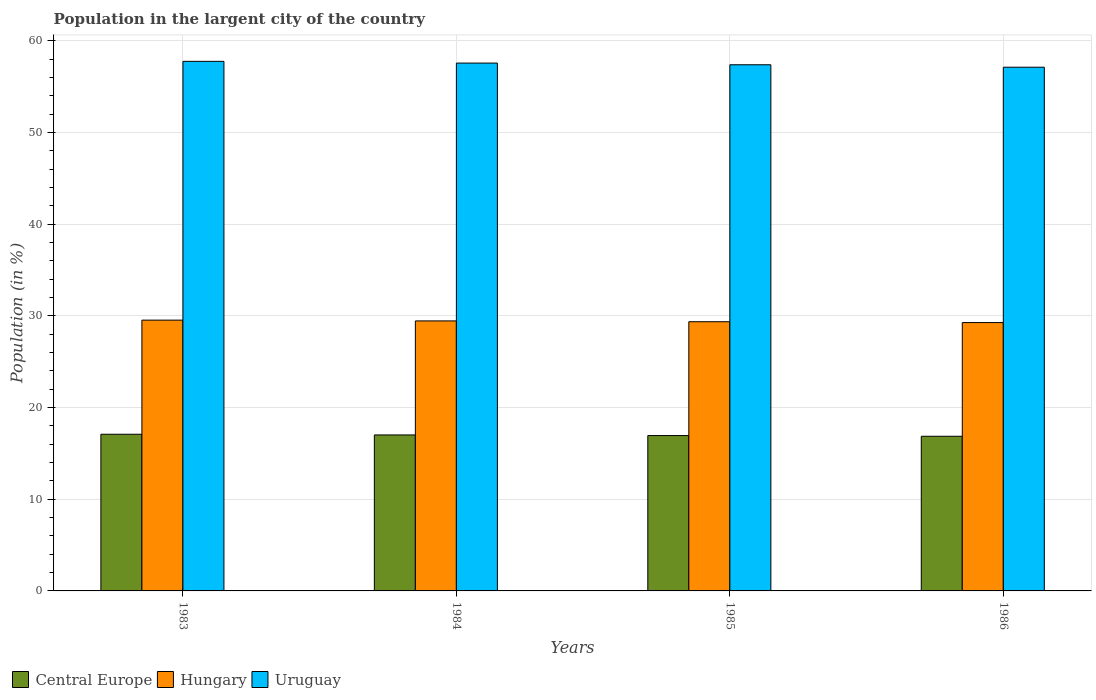How many different coloured bars are there?
Your answer should be compact. 3. How many groups of bars are there?
Your answer should be compact. 4. Are the number of bars on each tick of the X-axis equal?
Offer a terse response. Yes. How many bars are there on the 1st tick from the right?
Keep it short and to the point. 3. In how many cases, is the number of bars for a given year not equal to the number of legend labels?
Offer a very short reply. 0. What is the percentage of population in the largent city in Uruguay in 1983?
Give a very brief answer. 57.78. Across all years, what is the maximum percentage of population in the largent city in Uruguay?
Provide a short and direct response. 57.78. Across all years, what is the minimum percentage of population in the largent city in Central Europe?
Your answer should be compact. 16.87. In which year was the percentage of population in the largent city in Uruguay maximum?
Provide a short and direct response. 1983. What is the total percentage of population in the largent city in Uruguay in the graph?
Offer a very short reply. 229.9. What is the difference between the percentage of population in the largent city in Central Europe in 1985 and that in 1986?
Give a very brief answer. 0.08. What is the difference between the percentage of population in the largent city in Central Europe in 1985 and the percentage of population in the largent city in Hungary in 1984?
Offer a very short reply. -12.51. What is the average percentage of population in the largent city in Uruguay per year?
Offer a very short reply. 57.48. In the year 1986, what is the difference between the percentage of population in the largent city in Central Europe and percentage of population in the largent city in Uruguay?
Provide a short and direct response. -40.27. What is the ratio of the percentage of population in the largent city in Uruguay in 1983 to that in 1986?
Your answer should be very brief. 1.01. Is the percentage of population in the largent city in Central Europe in 1984 less than that in 1986?
Provide a short and direct response. No. Is the difference between the percentage of population in the largent city in Central Europe in 1984 and 1986 greater than the difference between the percentage of population in the largent city in Uruguay in 1984 and 1986?
Make the answer very short. No. What is the difference between the highest and the second highest percentage of population in the largent city in Uruguay?
Give a very brief answer. 0.19. What is the difference between the highest and the lowest percentage of population in the largent city in Central Europe?
Offer a very short reply. 0.22. In how many years, is the percentage of population in the largent city in Central Europe greater than the average percentage of population in the largent city in Central Europe taken over all years?
Provide a short and direct response. 2. What does the 1st bar from the left in 1983 represents?
Your response must be concise. Central Europe. What does the 1st bar from the right in 1984 represents?
Offer a terse response. Uruguay. Is it the case that in every year, the sum of the percentage of population in the largent city in Uruguay and percentage of population in the largent city in Hungary is greater than the percentage of population in the largent city in Central Europe?
Give a very brief answer. Yes. How many bars are there?
Give a very brief answer. 12. What is the difference between two consecutive major ticks on the Y-axis?
Provide a succinct answer. 10. How many legend labels are there?
Offer a terse response. 3. How are the legend labels stacked?
Your answer should be very brief. Horizontal. What is the title of the graph?
Your response must be concise. Population in the largent city of the country. What is the Population (in %) in Central Europe in 1983?
Give a very brief answer. 17.09. What is the Population (in %) of Hungary in 1983?
Your response must be concise. 29.54. What is the Population (in %) of Uruguay in 1983?
Make the answer very short. 57.78. What is the Population (in %) in Central Europe in 1984?
Give a very brief answer. 17.02. What is the Population (in %) of Hungary in 1984?
Ensure brevity in your answer.  29.46. What is the Population (in %) in Uruguay in 1984?
Offer a very short reply. 57.59. What is the Population (in %) of Central Europe in 1985?
Ensure brevity in your answer.  16.95. What is the Population (in %) in Hungary in 1985?
Offer a terse response. 29.37. What is the Population (in %) of Uruguay in 1985?
Your answer should be very brief. 57.4. What is the Population (in %) of Central Europe in 1986?
Offer a very short reply. 16.87. What is the Population (in %) in Hungary in 1986?
Provide a short and direct response. 29.28. What is the Population (in %) of Uruguay in 1986?
Offer a very short reply. 57.14. Across all years, what is the maximum Population (in %) of Central Europe?
Make the answer very short. 17.09. Across all years, what is the maximum Population (in %) of Hungary?
Make the answer very short. 29.54. Across all years, what is the maximum Population (in %) in Uruguay?
Offer a very short reply. 57.78. Across all years, what is the minimum Population (in %) in Central Europe?
Your answer should be compact. 16.87. Across all years, what is the minimum Population (in %) in Hungary?
Your answer should be very brief. 29.28. Across all years, what is the minimum Population (in %) in Uruguay?
Make the answer very short. 57.14. What is the total Population (in %) in Central Europe in the graph?
Keep it short and to the point. 67.93. What is the total Population (in %) of Hungary in the graph?
Your answer should be compact. 117.65. What is the total Population (in %) of Uruguay in the graph?
Ensure brevity in your answer.  229.9. What is the difference between the Population (in %) of Central Europe in 1983 and that in 1984?
Make the answer very short. 0.07. What is the difference between the Population (in %) in Hungary in 1983 and that in 1984?
Keep it short and to the point. 0.09. What is the difference between the Population (in %) in Uruguay in 1983 and that in 1984?
Make the answer very short. 0.19. What is the difference between the Population (in %) of Central Europe in 1983 and that in 1985?
Give a very brief answer. 0.14. What is the difference between the Population (in %) in Hungary in 1983 and that in 1985?
Offer a terse response. 0.17. What is the difference between the Population (in %) in Uruguay in 1983 and that in 1985?
Make the answer very short. 0.37. What is the difference between the Population (in %) in Central Europe in 1983 and that in 1986?
Ensure brevity in your answer.  0.22. What is the difference between the Population (in %) of Hungary in 1983 and that in 1986?
Ensure brevity in your answer.  0.27. What is the difference between the Population (in %) in Uruguay in 1983 and that in 1986?
Offer a terse response. 0.64. What is the difference between the Population (in %) in Central Europe in 1984 and that in 1985?
Offer a terse response. 0.07. What is the difference between the Population (in %) in Hungary in 1984 and that in 1985?
Keep it short and to the point. 0.09. What is the difference between the Population (in %) of Uruguay in 1984 and that in 1985?
Keep it short and to the point. 0.18. What is the difference between the Population (in %) of Central Europe in 1984 and that in 1986?
Ensure brevity in your answer.  0.14. What is the difference between the Population (in %) of Hungary in 1984 and that in 1986?
Provide a succinct answer. 0.18. What is the difference between the Population (in %) of Uruguay in 1984 and that in 1986?
Offer a terse response. 0.45. What is the difference between the Population (in %) in Central Europe in 1985 and that in 1986?
Make the answer very short. 0.08. What is the difference between the Population (in %) in Hungary in 1985 and that in 1986?
Make the answer very short. 0.09. What is the difference between the Population (in %) in Uruguay in 1985 and that in 1986?
Give a very brief answer. 0.27. What is the difference between the Population (in %) in Central Europe in 1983 and the Population (in %) in Hungary in 1984?
Your answer should be compact. -12.37. What is the difference between the Population (in %) in Central Europe in 1983 and the Population (in %) in Uruguay in 1984?
Your answer should be very brief. -40.49. What is the difference between the Population (in %) in Hungary in 1983 and the Population (in %) in Uruguay in 1984?
Offer a terse response. -28.04. What is the difference between the Population (in %) in Central Europe in 1983 and the Population (in %) in Hungary in 1985?
Your answer should be compact. -12.28. What is the difference between the Population (in %) of Central Europe in 1983 and the Population (in %) of Uruguay in 1985?
Keep it short and to the point. -40.31. What is the difference between the Population (in %) of Hungary in 1983 and the Population (in %) of Uruguay in 1985?
Your answer should be very brief. -27.86. What is the difference between the Population (in %) in Central Europe in 1983 and the Population (in %) in Hungary in 1986?
Ensure brevity in your answer.  -12.19. What is the difference between the Population (in %) in Central Europe in 1983 and the Population (in %) in Uruguay in 1986?
Keep it short and to the point. -40.05. What is the difference between the Population (in %) in Hungary in 1983 and the Population (in %) in Uruguay in 1986?
Your response must be concise. -27.59. What is the difference between the Population (in %) in Central Europe in 1984 and the Population (in %) in Hungary in 1985?
Ensure brevity in your answer.  -12.35. What is the difference between the Population (in %) of Central Europe in 1984 and the Population (in %) of Uruguay in 1985?
Provide a short and direct response. -40.39. What is the difference between the Population (in %) in Hungary in 1984 and the Population (in %) in Uruguay in 1985?
Offer a terse response. -27.95. What is the difference between the Population (in %) in Central Europe in 1984 and the Population (in %) in Hungary in 1986?
Your answer should be compact. -12.26. What is the difference between the Population (in %) in Central Europe in 1984 and the Population (in %) in Uruguay in 1986?
Provide a short and direct response. -40.12. What is the difference between the Population (in %) in Hungary in 1984 and the Population (in %) in Uruguay in 1986?
Your answer should be very brief. -27.68. What is the difference between the Population (in %) in Central Europe in 1985 and the Population (in %) in Hungary in 1986?
Your response must be concise. -12.33. What is the difference between the Population (in %) of Central Europe in 1985 and the Population (in %) of Uruguay in 1986?
Your answer should be very brief. -40.19. What is the difference between the Population (in %) in Hungary in 1985 and the Population (in %) in Uruguay in 1986?
Make the answer very short. -27.77. What is the average Population (in %) in Central Europe per year?
Give a very brief answer. 16.98. What is the average Population (in %) of Hungary per year?
Provide a succinct answer. 29.41. What is the average Population (in %) in Uruguay per year?
Ensure brevity in your answer.  57.48. In the year 1983, what is the difference between the Population (in %) of Central Europe and Population (in %) of Hungary?
Offer a terse response. -12.45. In the year 1983, what is the difference between the Population (in %) in Central Europe and Population (in %) in Uruguay?
Provide a short and direct response. -40.68. In the year 1983, what is the difference between the Population (in %) in Hungary and Population (in %) in Uruguay?
Keep it short and to the point. -28.23. In the year 1984, what is the difference between the Population (in %) in Central Europe and Population (in %) in Hungary?
Offer a very short reply. -12.44. In the year 1984, what is the difference between the Population (in %) in Central Europe and Population (in %) in Uruguay?
Your answer should be very brief. -40.57. In the year 1984, what is the difference between the Population (in %) of Hungary and Population (in %) of Uruguay?
Keep it short and to the point. -28.13. In the year 1985, what is the difference between the Population (in %) of Central Europe and Population (in %) of Hungary?
Your response must be concise. -12.42. In the year 1985, what is the difference between the Population (in %) of Central Europe and Population (in %) of Uruguay?
Your answer should be compact. -40.46. In the year 1985, what is the difference between the Population (in %) of Hungary and Population (in %) of Uruguay?
Provide a succinct answer. -28.03. In the year 1986, what is the difference between the Population (in %) of Central Europe and Population (in %) of Hungary?
Provide a succinct answer. -12.41. In the year 1986, what is the difference between the Population (in %) of Central Europe and Population (in %) of Uruguay?
Your response must be concise. -40.27. In the year 1986, what is the difference between the Population (in %) in Hungary and Population (in %) in Uruguay?
Offer a terse response. -27.86. What is the ratio of the Population (in %) in Uruguay in 1983 to that in 1984?
Give a very brief answer. 1. What is the ratio of the Population (in %) in Central Europe in 1983 to that in 1985?
Keep it short and to the point. 1.01. What is the ratio of the Population (in %) of Hungary in 1983 to that in 1985?
Your response must be concise. 1.01. What is the ratio of the Population (in %) of Central Europe in 1983 to that in 1986?
Make the answer very short. 1.01. What is the ratio of the Population (in %) in Hungary in 1983 to that in 1986?
Keep it short and to the point. 1.01. What is the ratio of the Population (in %) in Uruguay in 1983 to that in 1986?
Offer a very short reply. 1.01. What is the ratio of the Population (in %) in Central Europe in 1984 to that in 1985?
Your answer should be very brief. 1. What is the ratio of the Population (in %) of Central Europe in 1984 to that in 1986?
Give a very brief answer. 1.01. What is the ratio of the Population (in %) of Hungary in 1984 to that in 1986?
Offer a very short reply. 1.01. What is the ratio of the Population (in %) of Uruguay in 1984 to that in 1986?
Offer a very short reply. 1.01. What is the ratio of the Population (in %) of Central Europe in 1985 to that in 1986?
Give a very brief answer. 1. What is the ratio of the Population (in %) of Hungary in 1985 to that in 1986?
Offer a terse response. 1. What is the ratio of the Population (in %) in Uruguay in 1985 to that in 1986?
Offer a very short reply. 1. What is the difference between the highest and the second highest Population (in %) in Central Europe?
Offer a very short reply. 0.07. What is the difference between the highest and the second highest Population (in %) in Hungary?
Provide a short and direct response. 0.09. What is the difference between the highest and the second highest Population (in %) in Uruguay?
Make the answer very short. 0.19. What is the difference between the highest and the lowest Population (in %) in Central Europe?
Offer a terse response. 0.22. What is the difference between the highest and the lowest Population (in %) of Hungary?
Offer a very short reply. 0.27. What is the difference between the highest and the lowest Population (in %) of Uruguay?
Keep it short and to the point. 0.64. 